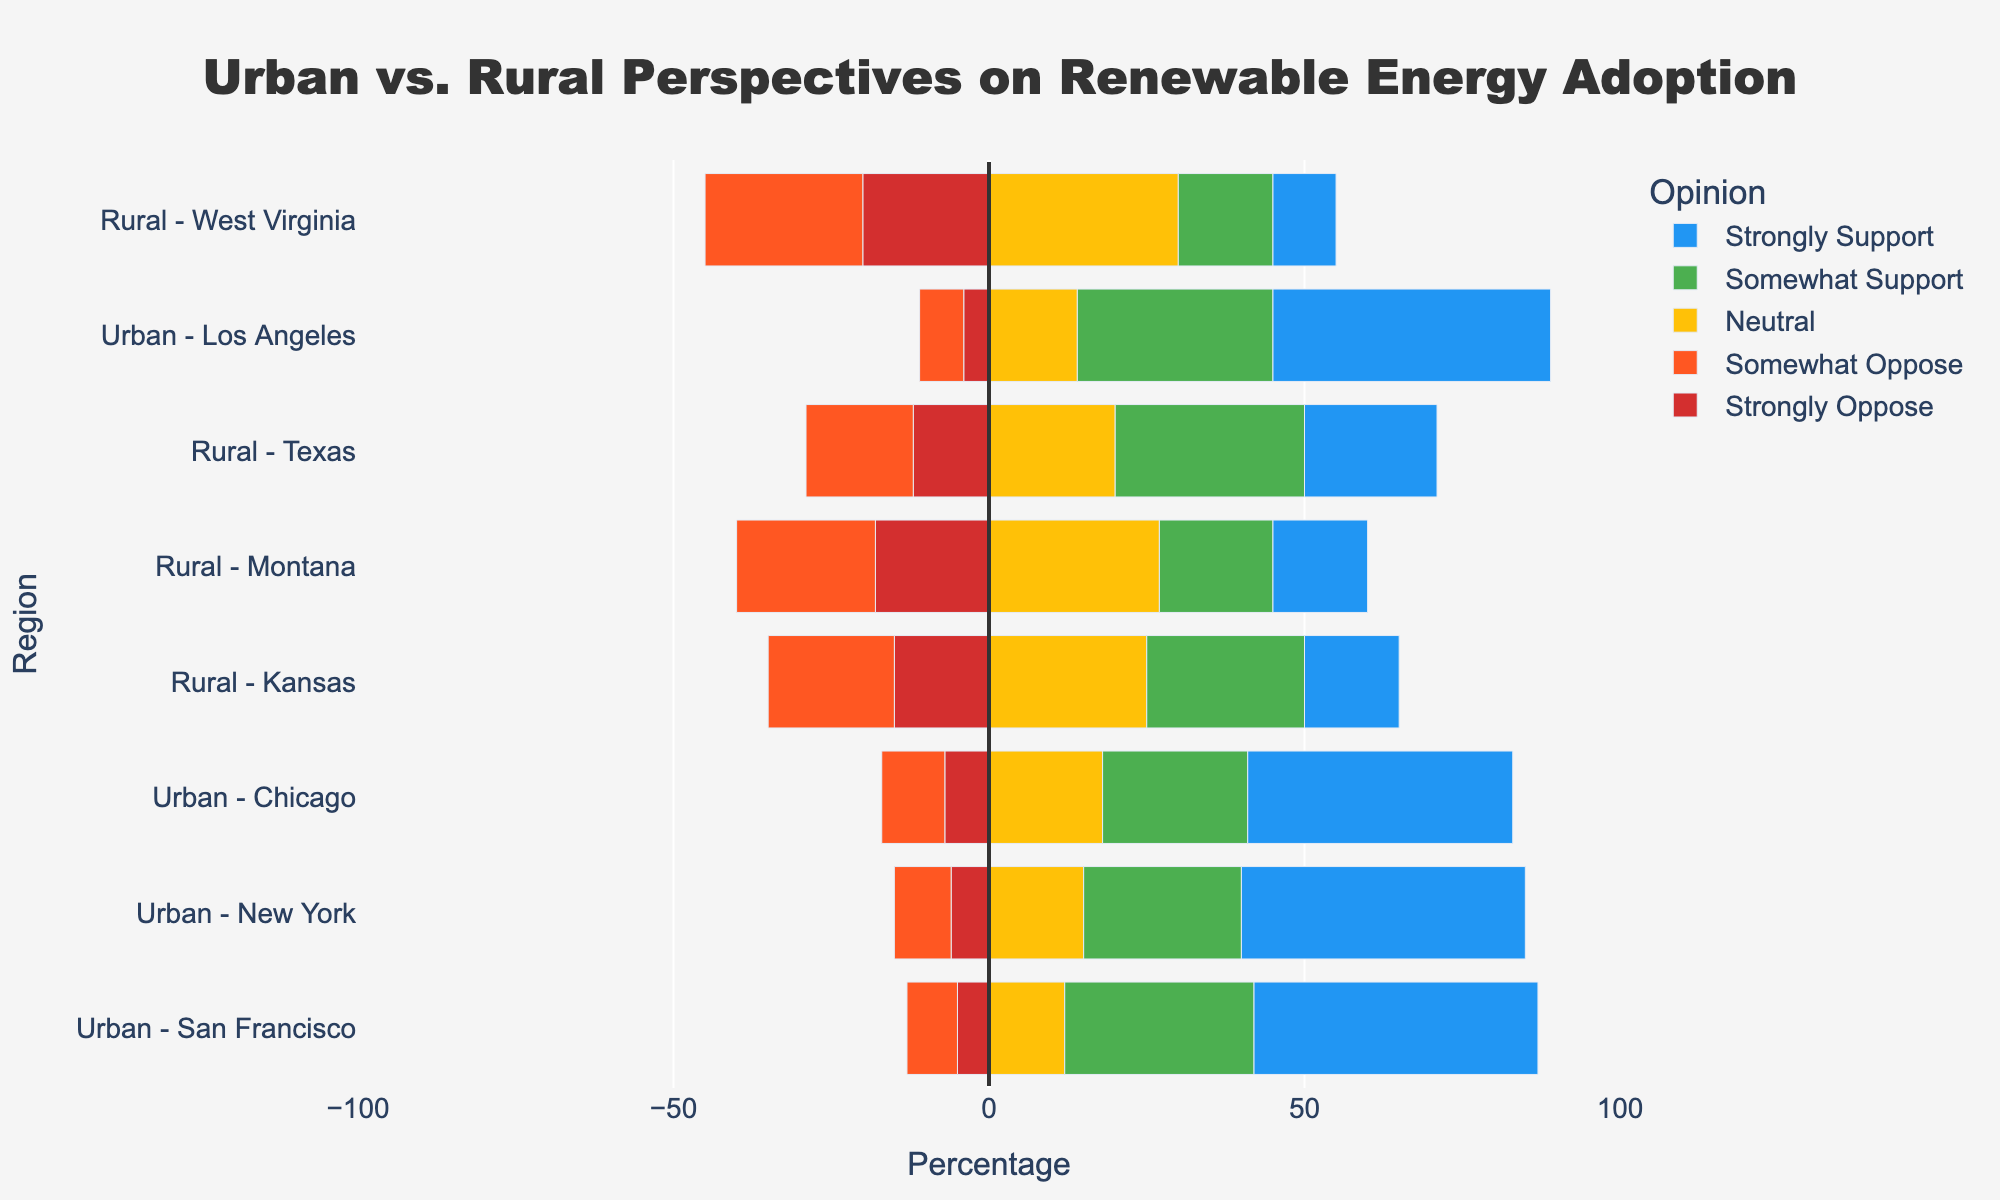What's the difference in the percentage of "Strongly Support" opinions between Urban - San Francisco and Rural - Montana? To find the difference, subtract the percentage for Rural - Montana from the percentage for Urban - San Francisco. The values are 45% and 15%, respectively. So, the difference is 45% - 15% = 30%.
Answer: 30% Which region has the highest percentage of "Strongly Support" opinions? By observing the length of the blue bars, Urban - San Francisco, Urban - New York, and Urban - Los Angeles all have the highest percentage at 45%.
Answer: Urban - San Francisco, Urban - New York, Urban - Los Angeles Compare the sum of percentages for "Strongly Oppose" and "Somewhat Oppose" between Urban - Chicago and Rural - West Virginia. Which one is higher? Sum the percentages for "Strongly Oppose" and "Somewhat Oppose" for both regions. Urban - Chicago: 7% + 10% = 17%. Rural - West Virginia: 20% + 25% = 45%. Rural - West Virginia is higher.
Answer: Rural - West Virginia Which region has the smallest percentage of "Somewhat Oppose" opinions? Look for the shortest orange bar. Urban - San Francisco has the smallest percentage at 8%.
Answer: Urban - San Francisco What's the average percentage of "Neutral" opinions for all rural regions? Sum the percentages for Rural - Kansas (25%), Rural - Montana (27%), Rural - Texas (20%), and Rural - West Virginia (30%) and divide by the number of rural regions. (25+27+20+30)/4 = 25.5%.
Answer: 25.5% In which region do the "Strongly Oppose" and "Somewhat Support" opinions add up to the same percentage? Examine the sum of "Strongly Oppose" and "Somewhat Support" for each region. Urban - New York: 6% + 25% = 31%. Urban - Chicago: 7% + 23% = 30%. Rural - Kansas: 15% + 25% = 40%. Rural - Montana: 18% + 18% = 36%. Rural - Texas: 12% + 30% = 42%. Urban - Los Angeles: 4% + 31% = 35%. Rural - West Virginia: 20% + 15% = 35%. None of the regions fit this criterion.
Answer: None Which has a higher percentage of "Neutral" opinions: Urban - Los Angeles or Rural - Texas? Compare the yellow bars. Urban - Los Angeles is 14%, and Rural - Texas is 20%. Rural - Texas is higher.
Answer: Rural - Texas Compare the total support percentages (both "Somewhat Support" and "Strongly Support") for Urban - Chicago and Rural - Texas. Which region shows more support? Sum the support percentages for both categories. Urban - Chicago: 23% + 42% = 65%. Rural - Texas: 30% + 21% = 51%. Urban - Chicago shows more support.
Answer: Urban - Chicago What is the total opposition percentage (both "Strongly Oppose" and "Somewhat Oppose") for Urban - San Francisco? Add the percentages of opposition categories. Urban - San Francisco: 5% + 8% = 13%.
Answer: 13% Is the percentage of "Strongly Oppose" opinions greater in any urban region compared to any rural region? The highest "Strongly Oppose" percentage in an urban region is Chicago with 7%. In rural regions, Kansas, Montana, Texas, and West Virginia all have values greater than 7%.
Answer: No 